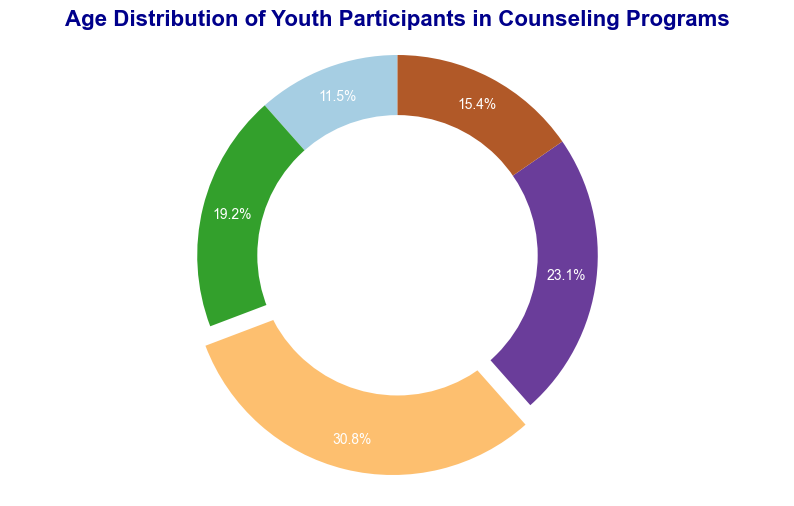What percentage of participants are in the 19-21 age group? Identify the slice labeled "19-21" on the pie chart. The percentage is marked within the slice's boundaries.
Answer: 24.0% Which age group has the highest number of participants? The largest slice in the pie chart has the age group labeled "16-18" with a percentage of 32.0%, indicating it has the highest number of participants.
Answer: 16-18 How many participants fall into the 22-24 age group? The total number of participants is 390 (sum of all participants). The percentage for the "22-24" age group is 15.4%, so multiply 390 by 0.154. The closest number of participants matching this is 60, as given.
Answer: 60 What is the combined percentage of participants aged 10-12 and 22-24? Identify the percentages for 10-12 and 22-24 age groups from the pie chart. Add 11.5% for 10-12 and 15.4% for 22-24.
Answer: 26.9% Is the 13-15 age group larger than the 22-24 age group? Compare the sizes of the slices labeled as 13-15 and 22-24. The 13-15 slice is larger with 19.2% compared to the 22-24 slice with 15.4%.
Answer: Yes Which age group has the smallest number of participants? Find the smallest slice in the pie chart, which is labeled "10-12" with 45 participants.
Answer: 10-12 By how many more participants does the 16-18 age group exceed the 13-15 age group? The 16-18 age group has 120 participants, and the 13-15 age group has 75 participants. Subtract 75 from 120 to find the difference.
Answer: 45 What is the combined total number of participants in the age groups 19-21 and 22-24? Add the number of participants in the 19-21 age group (90) to those in the 22-24 age group (60).
Answer: 150 What is the average number of participants per age group? The total number of participants is 390, divided by the five age groups. 390 divided by 5 equals 78.
Answer: 78 